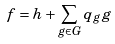Convert formula to latex. <formula><loc_0><loc_0><loc_500><loc_500>f = h + \sum _ { g \in G } q _ { g } g</formula> 